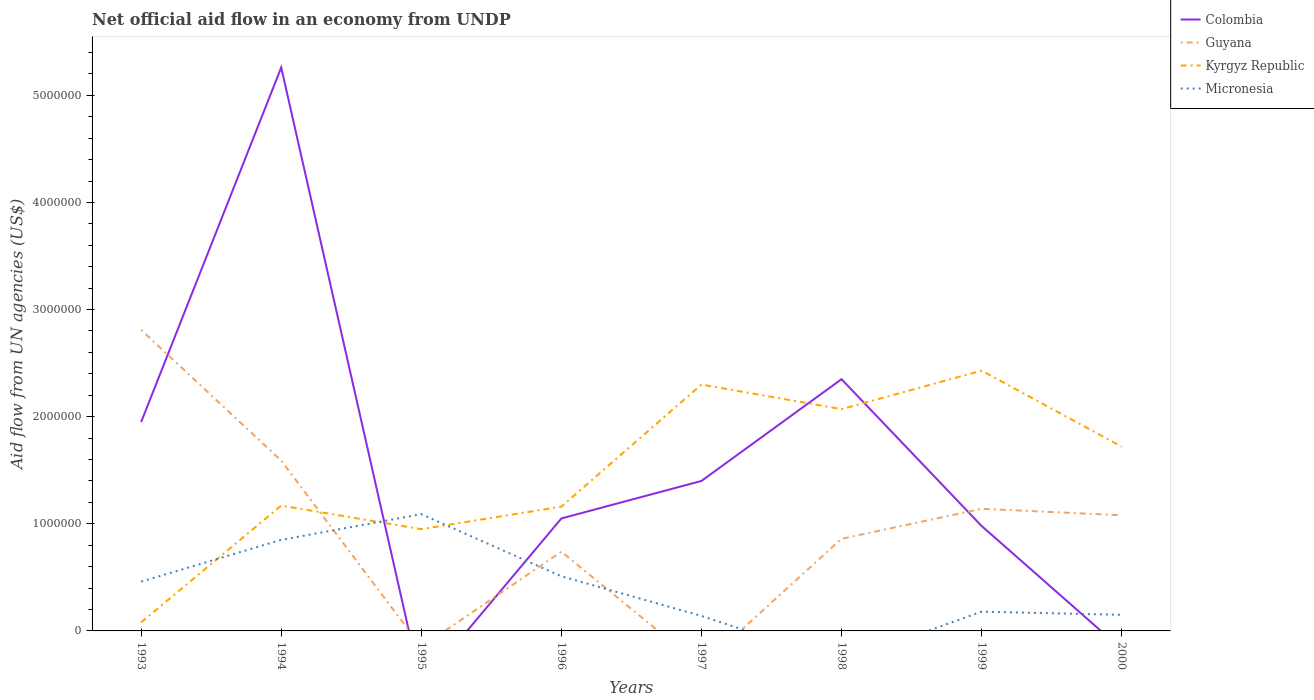How many different coloured lines are there?
Provide a succinct answer. 4. Is the number of lines equal to the number of legend labels?
Offer a terse response. No. Across all years, what is the maximum net official aid flow in Colombia?
Your response must be concise. 0. What is the difference between the highest and the second highest net official aid flow in Guyana?
Offer a terse response. 2.81e+06. What is the difference between the highest and the lowest net official aid flow in Micronesia?
Your response must be concise. 4. Is the net official aid flow in Kyrgyz Republic strictly greater than the net official aid flow in Micronesia over the years?
Ensure brevity in your answer.  No. How many lines are there?
Ensure brevity in your answer.  4. How many years are there in the graph?
Your answer should be very brief. 8. What is the difference between two consecutive major ticks on the Y-axis?
Your answer should be compact. 1.00e+06. Are the values on the major ticks of Y-axis written in scientific E-notation?
Keep it short and to the point. No. Does the graph contain any zero values?
Offer a very short reply. Yes. Does the graph contain grids?
Your response must be concise. No. How many legend labels are there?
Your response must be concise. 4. What is the title of the graph?
Keep it short and to the point. Net official aid flow in an economy from UNDP. What is the label or title of the Y-axis?
Your response must be concise. Aid flow from UN agencies (US$). What is the Aid flow from UN agencies (US$) in Colombia in 1993?
Offer a terse response. 1.95e+06. What is the Aid flow from UN agencies (US$) of Guyana in 1993?
Provide a short and direct response. 2.81e+06. What is the Aid flow from UN agencies (US$) of Kyrgyz Republic in 1993?
Provide a succinct answer. 8.00e+04. What is the Aid flow from UN agencies (US$) of Micronesia in 1993?
Keep it short and to the point. 4.60e+05. What is the Aid flow from UN agencies (US$) in Colombia in 1994?
Keep it short and to the point. 5.26e+06. What is the Aid flow from UN agencies (US$) in Guyana in 1994?
Make the answer very short. 1.59e+06. What is the Aid flow from UN agencies (US$) of Kyrgyz Republic in 1994?
Offer a terse response. 1.17e+06. What is the Aid flow from UN agencies (US$) of Micronesia in 1994?
Offer a very short reply. 8.50e+05. What is the Aid flow from UN agencies (US$) in Kyrgyz Republic in 1995?
Provide a short and direct response. 9.50e+05. What is the Aid flow from UN agencies (US$) of Micronesia in 1995?
Offer a very short reply. 1.09e+06. What is the Aid flow from UN agencies (US$) in Colombia in 1996?
Offer a very short reply. 1.05e+06. What is the Aid flow from UN agencies (US$) of Guyana in 1996?
Give a very brief answer. 7.40e+05. What is the Aid flow from UN agencies (US$) of Kyrgyz Republic in 1996?
Give a very brief answer. 1.16e+06. What is the Aid flow from UN agencies (US$) of Micronesia in 1996?
Give a very brief answer. 5.10e+05. What is the Aid flow from UN agencies (US$) in Colombia in 1997?
Provide a succinct answer. 1.40e+06. What is the Aid flow from UN agencies (US$) of Kyrgyz Republic in 1997?
Provide a short and direct response. 2.30e+06. What is the Aid flow from UN agencies (US$) of Colombia in 1998?
Your answer should be compact. 2.35e+06. What is the Aid flow from UN agencies (US$) of Guyana in 1998?
Make the answer very short. 8.60e+05. What is the Aid flow from UN agencies (US$) in Kyrgyz Republic in 1998?
Your response must be concise. 2.07e+06. What is the Aid flow from UN agencies (US$) in Micronesia in 1998?
Provide a succinct answer. 0. What is the Aid flow from UN agencies (US$) in Colombia in 1999?
Ensure brevity in your answer.  9.80e+05. What is the Aid flow from UN agencies (US$) of Guyana in 1999?
Provide a short and direct response. 1.14e+06. What is the Aid flow from UN agencies (US$) of Kyrgyz Republic in 1999?
Your answer should be very brief. 2.43e+06. What is the Aid flow from UN agencies (US$) of Colombia in 2000?
Ensure brevity in your answer.  0. What is the Aid flow from UN agencies (US$) in Guyana in 2000?
Ensure brevity in your answer.  1.08e+06. What is the Aid flow from UN agencies (US$) of Kyrgyz Republic in 2000?
Offer a terse response. 1.72e+06. What is the Aid flow from UN agencies (US$) of Micronesia in 2000?
Your answer should be compact. 1.50e+05. Across all years, what is the maximum Aid flow from UN agencies (US$) of Colombia?
Provide a succinct answer. 5.26e+06. Across all years, what is the maximum Aid flow from UN agencies (US$) in Guyana?
Provide a succinct answer. 2.81e+06. Across all years, what is the maximum Aid flow from UN agencies (US$) in Kyrgyz Republic?
Give a very brief answer. 2.43e+06. Across all years, what is the maximum Aid flow from UN agencies (US$) in Micronesia?
Your response must be concise. 1.09e+06. Across all years, what is the minimum Aid flow from UN agencies (US$) in Guyana?
Your answer should be very brief. 0. What is the total Aid flow from UN agencies (US$) in Colombia in the graph?
Provide a short and direct response. 1.30e+07. What is the total Aid flow from UN agencies (US$) of Guyana in the graph?
Your answer should be very brief. 8.22e+06. What is the total Aid flow from UN agencies (US$) in Kyrgyz Republic in the graph?
Offer a terse response. 1.19e+07. What is the total Aid flow from UN agencies (US$) in Micronesia in the graph?
Keep it short and to the point. 3.38e+06. What is the difference between the Aid flow from UN agencies (US$) of Colombia in 1993 and that in 1994?
Provide a succinct answer. -3.31e+06. What is the difference between the Aid flow from UN agencies (US$) of Guyana in 1993 and that in 1994?
Make the answer very short. 1.22e+06. What is the difference between the Aid flow from UN agencies (US$) in Kyrgyz Republic in 1993 and that in 1994?
Your answer should be compact. -1.09e+06. What is the difference between the Aid flow from UN agencies (US$) of Micronesia in 1993 and that in 1994?
Your answer should be very brief. -3.90e+05. What is the difference between the Aid flow from UN agencies (US$) of Kyrgyz Republic in 1993 and that in 1995?
Keep it short and to the point. -8.70e+05. What is the difference between the Aid flow from UN agencies (US$) of Micronesia in 1993 and that in 1995?
Offer a very short reply. -6.30e+05. What is the difference between the Aid flow from UN agencies (US$) in Guyana in 1993 and that in 1996?
Offer a very short reply. 2.07e+06. What is the difference between the Aid flow from UN agencies (US$) in Kyrgyz Republic in 1993 and that in 1996?
Offer a very short reply. -1.08e+06. What is the difference between the Aid flow from UN agencies (US$) of Kyrgyz Republic in 1993 and that in 1997?
Provide a succinct answer. -2.22e+06. What is the difference between the Aid flow from UN agencies (US$) of Micronesia in 1993 and that in 1997?
Keep it short and to the point. 3.20e+05. What is the difference between the Aid flow from UN agencies (US$) of Colombia in 1993 and that in 1998?
Your answer should be very brief. -4.00e+05. What is the difference between the Aid flow from UN agencies (US$) of Guyana in 1993 and that in 1998?
Offer a very short reply. 1.95e+06. What is the difference between the Aid flow from UN agencies (US$) in Kyrgyz Republic in 1993 and that in 1998?
Your answer should be compact. -1.99e+06. What is the difference between the Aid flow from UN agencies (US$) of Colombia in 1993 and that in 1999?
Offer a terse response. 9.70e+05. What is the difference between the Aid flow from UN agencies (US$) of Guyana in 1993 and that in 1999?
Offer a terse response. 1.67e+06. What is the difference between the Aid flow from UN agencies (US$) of Kyrgyz Republic in 1993 and that in 1999?
Your answer should be very brief. -2.35e+06. What is the difference between the Aid flow from UN agencies (US$) in Micronesia in 1993 and that in 1999?
Offer a terse response. 2.80e+05. What is the difference between the Aid flow from UN agencies (US$) in Guyana in 1993 and that in 2000?
Keep it short and to the point. 1.73e+06. What is the difference between the Aid flow from UN agencies (US$) in Kyrgyz Republic in 1993 and that in 2000?
Provide a succinct answer. -1.64e+06. What is the difference between the Aid flow from UN agencies (US$) of Micronesia in 1993 and that in 2000?
Your answer should be compact. 3.10e+05. What is the difference between the Aid flow from UN agencies (US$) of Kyrgyz Republic in 1994 and that in 1995?
Make the answer very short. 2.20e+05. What is the difference between the Aid flow from UN agencies (US$) in Micronesia in 1994 and that in 1995?
Provide a short and direct response. -2.40e+05. What is the difference between the Aid flow from UN agencies (US$) of Colombia in 1994 and that in 1996?
Give a very brief answer. 4.21e+06. What is the difference between the Aid flow from UN agencies (US$) of Guyana in 1994 and that in 1996?
Provide a succinct answer. 8.50e+05. What is the difference between the Aid flow from UN agencies (US$) in Kyrgyz Republic in 1994 and that in 1996?
Give a very brief answer. 10000. What is the difference between the Aid flow from UN agencies (US$) of Micronesia in 1994 and that in 1996?
Provide a short and direct response. 3.40e+05. What is the difference between the Aid flow from UN agencies (US$) in Colombia in 1994 and that in 1997?
Give a very brief answer. 3.86e+06. What is the difference between the Aid flow from UN agencies (US$) in Kyrgyz Republic in 1994 and that in 1997?
Ensure brevity in your answer.  -1.13e+06. What is the difference between the Aid flow from UN agencies (US$) in Micronesia in 1994 and that in 1997?
Provide a succinct answer. 7.10e+05. What is the difference between the Aid flow from UN agencies (US$) in Colombia in 1994 and that in 1998?
Offer a terse response. 2.91e+06. What is the difference between the Aid flow from UN agencies (US$) in Guyana in 1994 and that in 1998?
Your answer should be very brief. 7.30e+05. What is the difference between the Aid flow from UN agencies (US$) of Kyrgyz Republic in 1994 and that in 1998?
Ensure brevity in your answer.  -9.00e+05. What is the difference between the Aid flow from UN agencies (US$) of Colombia in 1994 and that in 1999?
Your answer should be very brief. 4.28e+06. What is the difference between the Aid flow from UN agencies (US$) of Guyana in 1994 and that in 1999?
Your response must be concise. 4.50e+05. What is the difference between the Aid flow from UN agencies (US$) in Kyrgyz Republic in 1994 and that in 1999?
Provide a short and direct response. -1.26e+06. What is the difference between the Aid flow from UN agencies (US$) in Micronesia in 1994 and that in 1999?
Provide a short and direct response. 6.70e+05. What is the difference between the Aid flow from UN agencies (US$) of Guyana in 1994 and that in 2000?
Give a very brief answer. 5.10e+05. What is the difference between the Aid flow from UN agencies (US$) of Kyrgyz Republic in 1994 and that in 2000?
Ensure brevity in your answer.  -5.50e+05. What is the difference between the Aid flow from UN agencies (US$) of Micronesia in 1995 and that in 1996?
Your response must be concise. 5.80e+05. What is the difference between the Aid flow from UN agencies (US$) of Kyrgyz Republic in 1995 and that in 1997?
Keep it short and to the point. -1.35e+06. What is the difference between the Aid flow from UN agencies (US$) in Micronesia in 1995 and that in 1997?
Offer a terse response. 9.50e+05. What is the difference between the Aid flow from UN agencies (US$) in Kyrgyz Republic in 1995 and that in 1998?
Offer a terse response. -1.12e+06. What is the difference between the Aid flow from UN agencies (US$) of Kyrgyz Republic in 1995 and that in 1999?
Give a very brief answer. -1.48e+06. What is the difference between the Aid flow from UN agencies (US$) of Micronesia in 1995 and that in 1999?
Give a very brief answer. 9.10e+05. What is the difference between the Aid flow from UN agencies (US$) in Kyrgyz Republic in 1995 and that in 2000?
Your answer should be compact. -7.70e+05. What is the difference between the Aid flow from UN agencies (US$) in Micronesia in 1995 and that in 2000?
Your answer should be very brief. 9.40e+05. What is the difference between the Aid flow from UN agencies (US$) in Colombia in 1996 and that in 1997?
Offer a very short reply. -3.50e+05. What is the difference between the Aid flow from UN agencies (US$) of Kyrgyz Republic in 1996 and that in 1997?
Give a very brief answer. -1.14e+06. What is the difference between the Aid flow from UN agencies (US$) in Colombia in 1996 and that in 1998?
Your response must be concise. -1.30e+06. What is the difference between the Aid flow from UN agencies (US$) of Kyrgyz Republic in 1996 and that in 1998?
Provide a succinct answer. -9.10e+05. What is the difference between the Aid flow from UN agencies (US$) of Colombia in 1996 and that in 1999?
Your answer should be compact. 7.00e+04. What is the difference between the Aid flow from UN agencies (US$) in Guyana in 1996 and that in 1999?
Your response must be concise. -4.00e+05. What is the difference between the Aid flow from UN agencies (US$) in Kyrgyz Republic in 1996 and that in 1999?
Provide a short and direct response. -1.27e+06. What is the difference between the Aid flow from UN agencies (US$) in Micronesia in 1996 and that in 1999?
Provide a succinct answer. 3.30e+05. What is the difference between the Aid flow from UN agencies (US$) of Guyana in 1996 and that in 2000?
Provide a succinct answer. -3.40e+05. What is the difference between the Aid flow from UN agencies (US$) in Kyrgyz Republic in 1996 and that in 2000?
Give a very brief answer. -5.60e+05. What is the difference between the Aid flow from UN agencies (US$) of Micronesia in 1996 and that in 2000?
Provide a short and direct response. 3.60e+05. What is the difference between the Aid flow from UN agencies (US$) in Colombia in 1997 and that in 1998?
Offer a very short reply. -9.50e+05. What is the difference between the Aid flow from UN agencies (US$) in Kyrgyz Republic in 1997 and that in 1998?
Keep it short and to the point. 2.30e+05. What is the difference between the Aid flow from UN agencies (US$) in Colombia in 1997 and that in 1999?
Provide a short and direct response. 4.20e+05. What is the difference between the Aid flow from UN agencies (US$) in Kyrgyz Republic in 1997 and that in 1999?
Provide a succinct answer. -1.30e+05. What is the difference between the Aid flow from UN agencies (US$) in Kyrgyz Republic in 1997 and that in 2000?
Your response must be concise. 5.80e+05. What is the difference between the Aid flow from UN agencies (US$) of Micronesia in 1997 and that in 2000?
Provide a short and direct response. -10000. What is the difference between the Aid flow from UN agencies (US$) of Colombia in 1998 and that in 1999?
Ensure brevity in your answer.  1.37e+06. What is the difference between the Aid flow from UN agencies (US$) of Guyana in 1998 and that in 1999?
Your answer should be compact. -2.80e+05. What is the difference between the Aid flow from UN agencies (US$) in Kyrgyz Republic in 1998 and that in 1999?
Your answer should be compact. -3.60e+05. What is the difference between the Aid flow from UN agencies (US$) in Guyana in 1998 and that in 2000?
Offer a very short reply. -2.20e+05. What is the difference between the Aid flow from UN agencies (US$) in Guyana in 1999 and that in 2000?
Offer a terse response. 6.00e+04. What is the difference between the Aid flow from UN agencies (US$) of Kyrgyz Republic in 1999 and that in 2000?
Your answer should be compact. 7.10e+05. What is the difference between the Aid flow from UN agencies (US$) in Colombia in 1993 and the Aid flow from UN agencies (US$) in Kyrgyz Republic in 1994?
Provide a succinct answer. 7.80e+05. What is the difference between the Aid flow from UN agencies (US$) in Colombia in 1993 and the Aid flow from UN agencies (US$) in Micronesia in 1994?
Provide a succinct answer. 1.10e+06. What is the difference between the Aid flow from UN agencies (US$) in Guyana in 1993 and the Aid flow from UN agencies (US$) in Kyrgyz Republic in 1994?
Offer a very short reply. 1.64e+06. What is the difference between the Aid flow from UN agencies (US$) of Guyana in 1993 and the Aid flow from UN agencies (US$) of Micronesia in 1994?
Make the answer very short. 1.96e+06. What is the difference between the Aid flow from UN agencies (US$) in Kyrgyz Republic in 1993 and the Aid flow from UN agencies (US$) in Micronesia in 1994?
Keep it short and to the point. -7.70e+05. What is the difference between the Aid flow from UN agencies (US$) in Colombia in 1993 and the Aid flow from UN agencies (US$) in Kyrgyz Republic in 1995?
Give a very brief answer. 1.00e+06. What is the difference between the Aid flow from UN agencies (US$) in Colombia in 1993 and the Aid flow from UN agencies (US$) in Micronesia in 1995?
Make the answer very short. 8.60e+05. What is the difference between the Aid flow from UN agencies (US$) of Guyana in 1993 and the Aid flow from UN agencies (US$) of Kyrgyz Republic in 1995?
Keep it short and to the point. 1.86e+06. What is the difference between the Aid flow from UN agencies (US$) in Guyana in 1993 and the Aid flow from UN agencies (US$) in Micronesia in 1995?
Give a very brief answer. 1.72e+06. What is the difference between the Aid flow from UN agencies (US$) of Kyrgyz Republic in 1993 and the Aid flow from UN agencies (US$) of Micronesia in 1995?
Offer a terse response. -1.01e+06. What is the difference between the Aid flow from UN agencies (US$) in Colombia in 1993 and the Aid flow from UN agencies (US$) in Guyana in 1996?
Your answer should be very brief. 1.21e+06. What is the difference between the Aid flow from UN agencies (US$) in Colombia in 1993 and the Aid flow from UN agencies (US$) in Kyrgyz Republic in 1996?
Make the answer very short. 7.90e+05. What is the difference between the Aid flow from UN agencies (US$) in Colombia in 1993 and the Aid flow from UN agencies (US$) in Micronesia in 1996?
Provide a short and direct response. 1.44e+06. What is the difference between the Aid flow from UN agencies (US$) of Guyana in 1993 and the Aid flow from UN agencies (US$) of Kyrgyz Republic in 1996?
Provide a short and direct response. 1.65e+06. What is the difference between the Aid flow from UN agencies (US$) of Guyana in 1993 and the Aid flow from UN agencies (US$) of Micronesia in 1996?
Give a very brief answer. 2.30e+06. What is the difference between the Aid flow from UN agencies (US$) in Kyrgyz Republic in 1993 and the Aid flow from UN agencies (US$) in Micronesia in 1996?
Make the answer very short. -4.30e+05. What is the difference between the Aid flow from UN agencies (US$) in Colombia in 1993 and the Aid flow from UN agencies (US$) in Kyrgyz Republic in 1997?
Keep it short and to the point. -3.50e+05. What is the difference between the Aid flow from UN agencies (US$) in Colombia in 1993 and the Aid flow from UN agencies (US$) in Micronesia in 1997?
Offer a very short reply. 1.81e+06. What is the difference between the Aid flow from UN agencies (US$) of Guyana in 1993 and the Aid flow from UN agencies (US$) of Kyrgyz Republic in 1997?
Give a very brief answer. 5.10e+05. What is the difference between the Aid flow from UN agencies (US$) of Guyana in 1993 and the Aid flow from UN agencies (US$) of Micronesia in 1997?
Make the answer very short. 2.67e+06. What is the difference between the Aid flow from UN agencies (US$) of Kyrgyz Republic in 1993 and the Aid flow from UN agencies (US$) of Micronesia in 1997?
Offer a terse response. -6.00e+04. What is the difference between the Aid flow from UN agencies (US$) in Colombia in 1993 and the Aid flow from UN agencies (US$) in Guyana in 1998?
Provide a short and direct response. 1.09e+06. What is the difference between the Aid flow from UN agencies (US$) in Colombia in 1993 and the Aid flow from UN agencies (US$) in Kyrgyz Republic in 1998?
Make the answer very short. -1.20e+05. What is the difference between the Aid flow from UN agencies (US$) of Guyana in 1993 and the Aid flow from UN agencies (US$) of Kyrgyz Republic in 1998?
Ensure brevity in your answer.  7.40e+05. What is the difference between the Aid flow from UN agencies (US$) in Colombia in 1993 and the Aid flow from UN agencies (US$) in Guyana in 1999?
Offer a terse response. 8.10e+05. What is the difference between the Aid flow from UN agencies (US$) of Colombia in 1993 and the Aid flow from UN agencies (US$) of Kyrgyz Republic in 1999?
Provide a short and direct response. -4.80e+05. What is the difference between the Aid flow from UN agencies (US$) of Colombia in 1993 and the Aid flow from UN agencies (US$) of Micronesia in 1999?
Give a very brief answer. 1.77e+06. What is the difference between the Aid flow from UN agencies (US$) of Guyana in 1993 and the Aid flow from UN agencies (US$) of Kyrgyz Republic in 1999?
Provide a short and direct response. 3.80e+05. What is the difference between the Aid flow from UN agencies (US$) in Guyana in 1993 and the Aid flow from UN agencies (US$) in Micronesia in 1999?
Provide a succinct answer. 2.63e+06. What is the difference between the Aid flow from UN agencies (US$) in Kyrgyz Republic in 1993 and the Aid flow from UN agencies (US$) in Micronesia in 1999?
Give a very brief answer. -1.00e+05. What is the difference between the Aid flow from UN agencies (US$) in Colombia in 1993 and the Aid flow from UN agencies (US$) in Guyana in 2000?
Ensure brevity in your answer.  8.70e+05. What is the difference between the Aid flow from UN agencies (US$) in Colombia in 1993 and the Aid flow from UN agencies (US$) in Micronesia in 2000?
Provide a succinct answer. 1.80e+06. What is the difference between the Aid flow from UN agencies (US$) in Guyana in 1993 and the Aid flow from UN agencies (US$) in Kyrgyz Republic in 2000?
Ensure brevity in your answer.  1.09e+06. What is the difference between the Aid flow from UN agencies (US$) in Guyana in 1993 and the Aid flow from UN agencies (US$) in Micronesia in 2000?
Make the answer very short. 2.66e+06. What is the difference between the Aid flow from UN agencies (US$) of Colombia in 1994 and the Aid flow from UN agencies (US$) of Kyrgyz Republic in 1995?
Your answer should be very brief. 4.31e+06. What is the difference between the Aid flow from UN agencies (US$) of Colombia in 1994 and the Aid flow from UN agencies (US$) of Micronesia in 1995?
Give a very brief answer. 4.17e+06. What is the difference between the Aid flow from UN agencies (US$) of Guyana in 1994 and the Aid flow from UN agencies (US$) of Kyrgyz Republic in 1995?
Make the answer very short. 6.40e+05. What is the difference between the Aid flow from UN agencies (US$) of Colombia in 1994 and the Aid flow from UN agencies (US$) of Guyana in 1996?
Ensure brevity in your answer.  4.52e+06. What is the difference between the Aid flow from UN agencies (US$) in Colombia in 1994 and the Aid flow from UN agencies (US$) in Kyrgyz Republic in 1996?
Your answer should be very brief. 4.10e+06. What is the difference between the Aid flow from UN agencies (US$) of Colombia in 1994 and the Aid flow from UN agencies (US$) of Micronesia in 1996?
Offer a very short reply. 4.75e+06. What is the difference between the Aid flow from UN agencies (US$) of Guyana in 1994 and the Aid flow from UN agencies (US$) of Micronesia in 1996?
Provide a succinct answer. 1.08e+06. What is the difference between the Aid flow from UN agencies (US$) in Kyrgyz Republic in 1994 and the Aid flow from UN agencies (US$) in Micronesia in 1996?
Ensure brevity in your answer.  6.60e+05. What is the difference between the Aid flow from UN agencies (US$) in Colombia in 1994 and the Aid flow from UN agencies (US$) in Kyrgyz Republic in 1997?
Provide a short and direct response. 2.96e+06. What is the difference between the Aid flow from UN agencies (US$) in Colombia in 1994 and the Aid flow from UN agencies (US$) in Micronesia in 1997?
Provide a succinct answer. 5.12e+06. What is the difference between the Aid flow from UN agencies (US$) in Guyana in 1994 and the Aid flow from UN agencies (US$) in Kyrgyz Republic in 1997?
Give a very brief answer. -7.10e+05. What is the difference between the Aid flow from UN agencies (US$) of Guyana in 1994 and the Aid flow from UN agencies (US$) of Micronesia in 1997?
Keep it short and to the point. 1.45e+06. What is the difference between the Aid flow from UN agencies (US$) of Kyrgyz Republic in 1994 and the Aid flow from UN agencies (US$) of Micronesia in 1997?
Your answer should be compact. 1.03e+06. What is the difference between the Aid flow from UN agencies (US$) in Colombia in 1994 and the Aid flow from UN agencies (US$) in Guyana in 1998?
Provide a succinct answer. 4.40e+06. What is the difference between the Aid flow from UN agencies (US$) in Colombia in 1994 and the Aid flow from UN agencies (US$) in Kyrgyz Republic in 1998?
Provide a succinct answer. 3.19e+06. What is the difference between the Aid flow from UN agencies (US$) in Guyana in 1994 and the Aid flow from UN agencies (US$) in Kyrgyz Republic in 1998?
Keep it short and to the point. -4.80e+05. What is the difference between the Aid flow from UN agencies (US$) of Colombia in 1994 and the Aid flow from UN agencies (US$) of Guyana in 1999?
Give a very brief answer. 4.12e+06. What is the difference between the Aid flow from UN agencies (US$) in Colombia in 1994 and the Aid flow from UN agencies (US$) in Kyrgyz Republic in 1999?
Make the answer very short. 2.83e+06. What is the difference between the Aid flow from UN agencies (US$) of Colombia in 1994 and the Aid flow from UN agencies (US$) of Micronesia in 1999?
Offer a terse response. 5.08e+06. What is the difference between the Aid flow from UN agencies (US$) in Guyana in 1994 and the Aid flow from UN agencies (US$) in Kyrgyz Republic in 1999?
Your answer should be compact. -8.40e+05. What is the difference between the Aid flow from UN agencies (US$) of Guyana in 1994 and the Aid flow from UN agencies (US$) of Micronesia in 1999?
Keep it short and to the point. 1.41e+06. What is the difference between the Aid flow from UN agencies (US$) in Kyrgyz Republic in 1994 and the Aid flow from UN agencies (US$) in Micronesia in 1999?
Provide a short and direct response. 9.90e+05. What is the difference between the Aid flow from UN agencies (US$) in Colombia in 1994 and the Aid flow from UN agencies (US$) in Guyana in 2000?
Your answer should be compact. 4.18e+06. What is the difference between the Aid flow from UN agencies (US$) of Colombia in 1994 and the Aid flow from UN agencies (US$) of Kyrgyz Republic in 2000?
Your answer should be compact. 3.54e+06. What is the difference between the Aid flow from UN agencies (US$) in Colombia in 1994 and the Aid flow from UN agencies (US$) in Micronesia in 2000?
Make the answer very short. 5.11e+06. What is the difference between the Aid flow from UN agencies (US$) in Guyana in 1994 and the Aid flow from UN agencies (US$) in Micronesia in 2000?
Your response must be concise. 1.44e+06. What is the difference between the Aid flow from UN agencies (US$) of Kyrgyz Republic in 1994 and the Aid flow from UN agencies (US$) of Micronesia in 2000?
Give a very brief answer. 1.02e+06. What is the difference between the Aid flow from UN agencies (US$) of Kyrgyz Republic in 1995 and the Aid flow from UN agencies (US$) of Micronesia in 1996?
Provide a succinct answer. 4.40e+05. What is the difference between the Aid flow from UN agencies (US$) of Kyrgyz Republic in 1995 and the Aid flow from UN agencies (US$) of Micronesia in 1997?
Ensure brevity in your answer.  8.10e+05. What is the difference between the Aid flow from UN agencies (US$) of Kyrgyz Republic in 1995 and the Aid flow from UN agencies (US$) of Micronesia in 1999?
Offer a terse response. 7.70e+05. What is the difference between the Aid flow from UN agencies (US$) in Colombia in 1996 and the Aid flow from UN agencies (US$) in Kyrgyz Republic in 1997?
Provide a succinct answer. -1.25e+06. What is the difference between the Aid flow from UN agencies (US$) in Colombia in 1996 and the Aid flow from UN agencies (US$) in Micronesia in 1997?
Your answer should be compact. 9.10e+05. What is the difference between the Aid flow from UN agencies (US$) of Guyana in 1996 and the Aid flow from UN agencies (US$) of Kyrgyz Republic in 1997?
Offer a very short reply. -1.56e+06. What is the difference between the Aid flow from UN agencies (US$) of Guyana in 1996 and the Aid flow from UN agencies (US$) of Micronesia in 1997?
Provide a short and direct response. 6.00e+05. What is the difference between the Aid flow from UN agencies (US$) of Kyrgyz Republic in 1996 and the Aid flow from UN agencies (US$) of Micronesia in 1997?
Provide a succinct answer. 1.02e+06. What is the difference between the Aid flow from UN agencies (US$) of Colombia in 1996 and the Aid flow from UN agencies (US$) of Guyana in 1998?
Give a very brief answer. 1.90e+05. What is the difference between the Aid flow from UN agencies (US$) of Colombia in 1996 and the Aid flow from UN agencies (US$) of Kyrgyz Republic in 1998?
Make the answer very short. -1.02e+06. What is the difference between the Aid flow from UN agencies (US$) in Guyana in 1996 and the Aid flow from UN agencies (US$) in Kyrgyz Republic in 1998?
Give a very brief answer. -1.33e+06. What is the difference between the Aid flow from UN agencies (US$) of Colombia in 1996 and the Aid flow from UN agencies (US$) of Kyrgyz Republic in 1999?
Provide a succinct answer. -1.38e+06. What is the difference between the Aid flow from UN agencies (US$) of Colombia in 1996 and the Aid flow from UN agencies (US$) of Micronesia in 1999?
Offer a terse response. 8.70e+05. What is the difference between the Aid flow from UN agencies (US$) in Guyana in 1996 and the Aid flow from UN agencies (US$) in Kyrgyz Republic in 1999?
Your answer should be compact. -1.69e+06. What is the difference between the Aid flow from UN agencies (US$) in Guyana in 1996 and the Aid flow from UN agencies (US$) in Micronesia in 1999?
Provide a succinct answer. 5.60e+05. What is the difference between the Aid flow from UN agencies (US$) of Kyrgyz Republic in 1996 and the Aid flow from UN agencies (US$) of Micronesia in 1999?
Your answer should be very brief. 9.80e+05. What is the difference between the Aid flow from UN agencies (US$) in Colombia in 1996 and the Aid flow from UN agencies (US$) in Kyrgyz Republic in 2000?
Your response must be concise. -6.70e+05. What is the difference between the Aid flow from UN agencies (US$) in Guyana in 1996 and the Aid flow from UN agencies (US$) in Kyrgyz Republic in 2000?
Provide a short and direct response. -9.80e+05. What is the difference between the Aid flow from UN agencies (US$) in Guyana in 1996 and the Aid flow from UN agencies (US$) in Micronesia in 2000?
Offer a very short reply. 5.90e+05. What is the difference between the Aid flow from UN agencies (US$) in Kyrgyz Republic in 1996 and the Aid flow from UN agencies (US$) in Micronesia in 2000?
Ensure brevity in your answer.  1.01e+06. What is the difference between the Aid flow from UN agencies (US$) of Colombia in 1997 and the Aid flow from UN agencies (US$) of Guyana in 1998?
Provide a short and direct response. 5.40e+05. What is the difference between the Aid flow from UN agencies (US$) of Colombia in 1997 and the Aid flow from UN agencies (US$) of Kyrgyz Republic in 1998?
Make the answer very short. -6.70e+05. What is the difference between the Aid flow from UN agencies (US$) of Colombia in 1997 and the Aid flow from UN agencies (US$) of Guyana in 1999?
Give a very brief answer. 2.60e+05. What is the difference between the Aid flow from UN agencies (US$) of Colombia in 1997 and the Aid flow from UN agencies (US$) of Kyrgyz Republic in 1999?
Provide a short and direct response. -1.03e+06. What is the difference between the Aid flow from UN agencies (US$) in Colombia in 1997 and the Aid flow from UN agencies (US$) in Micronesia in 1999?
Offer a very short reply. 1.22e+06. What is the difference between the Aid flow from UN agencies (US$) in Kyrgyz Republic in 1997 and the Aid flow from UN agencies (US$) in Micronesia in 1999?
Give a very brief answer. 2.12e+06. What is the difference between the Aid flow from UN agencies (US$) of Colombia in 1997 and the Aid flow from UN agencies (US$) of Guyana in 2000?
Keep it short and to the point. 3.20e+05. What is the difference between the Aid flow from UN agencies (US$) of Colombia in 1997 and the Aid flow from UN agencies (US$) of Kyrgyz Republic in 2000?
Make the answer very short. -3.20e+05. What is the difference between the Aid flow from UN agencies (US$) in Colombia in 1997 and the Aid flow from UN agencies (US$) in Micronesia in 2000?
Your answer should be very brief. 1.25e+06. What is the difference between the Aid flow from UN agencies (US$) in Kyrgyz Republic in 1997 and the Aid flow from UN agencies (US$) in Micronesia in 2000?
Give a very brief answer. 2.15e+06. What is the difference between the Aid flow from UN agencies (US$) in Colombia in 1998 and the Aid flow from UN agencies (US$) in Guyana in 1999?
Provide a short and direct response. 1.21e+06. What is the difference between the Aid flow from UN agencies (US$) of Colombia in 1998 and the Aid flow from UN agencies (US$) of Micronesia in 1999?
Provide a short and direct response. 2.17e+06. What is the difference between the Aid flow from UN agencies (US$) in Guyana in 1998 and the Aid flow from UN agencies (US$) in Kyrgyz Republic in 1999?
Your answer should be compact. -1.57e+06. What is the difference between the Aid flow from UN agencies (US$) in Guyana in 1998 and the Aid flow from UN agencies (US$) in Micronesia in 1999?
Keep it short and to the point. 6.80e+05. What is the difference between the Aid flow from UN agencies (US$) in Kyrgyz Republic in 1998 and the Aid flow from UN agencies (US$) in Micronesia in 1999?
Your answer should be compact. 1.89e+06. What is the difference between the Aid flow from UN agencies (US$) of Colombia in 1998 and the Aid flow from UN agencies (US$) of Guyana in 2000?
Ensure brevity in your answer.  1.27e+06. What is the difference between the Aid flow from UN agencies (US$) of Colombia in 1998 and the Aid flow from UN agencies (US$) of Kyrgyz Republic in 2000?
Provide a succinct answer. 6.30e+05. What is the difference between the Aid flow from UN agencies (US$) of Colombia in 1998 and the Aid flow from UN agencies (US$) of Micronesia in 2000?
Offer a very short reply. 2.20e+06. What is the difference between the Aid flow from UN agencies (US$) of Guyana in 1998 and the Aid flow from UN agencies (US$) of Kyrgyz Republic in 2000?
Give a very brief answer. -8.60e+05. What is the difference between the Aid flow from UN agencies (US$) of Guyana in 1998 and the Aid flow from UN agencies (US$) of Micronesia in 2000?
Provide a succinct answer. 7.10e+05. What is the difference between the Aid flow from UN agencies (US$) of Kyrgyz Republic in 1998 and the Aid flow from UN agencies (US$) of Micronesia in 2000?
Offer a terse response. 1.92e+06. What is the difference between the Aid flow from UN agencies (US$) in Colombia in 1999 and the Aid flow from UN agencies (US$) in Kyrgyz Republic in 2000?
Provide a succinct answer. -7.40e+05. What is the difference between the Aid flow from UN agencies (US$) in Colombia in 1999 and the Aid flow from UN agencies (US$) in Micronesia in 2000?
Keep it short and to the point. 8.30e+05. What is the difference between the Aid flow from UN agencies (US$) in Guyana in 1999 and the Aid flow from UN agencies (US$) in Kyrgyz Republic in 2000?
Your answer should be compact. -5.80e+05. What is the difference between the Aid flow from UN agencies (US$) in Guyana in 1999 and the Aid flow from UN agencies (US$) in Micronesia in 2000?
Give a very brief answer. 9.90e+05. What is the difference between the Aid flow from UN agencies (US$) of Kyrgyz Republic in 1999 and the Aid flow from UN agencies (US$) of Micronesia in 2000?
Provide a short and direct response. 2.28e+06. What is the average Aid flow from UN agencies (US$) of Colombia per year?
Make the answer very short. 1.62e+06. What is the average Aid flow from UN agencies (US$) of Guyana per year?
Your answer should be compact. 1.03e+06. What is the average Aid flow from UN agencies (US$) of Kyrgyz Republic per year?
Your answer should be very brief. 1.48e+06. What is the average Aid flow from UN agencies (US$) of Micronesia per year?
Provide a short and direct response. 4.22e+05. In the year 1993, what is the difference between the Aid flow from UN agencies (US$) in Colombia and Aid flow from UN agencies (US$) in Guyana?
Your response must be concise. -8.60e+05. In the year 1993, what is the difference between the Aid flow from UN agencies (US$) of Colombia and Aid flow from UN agencies (US$) of Kyrgyz Republic?
Your response must be concise. 1.87e+06. In the year 1993, what is the difference between the Aid flow from UN agencies (US$) in Colombia and Aid flow from UN agencies (US$) in Micronesia?
Your answer should be very brief. 1.49e+06. In the year 1993, what is the difference between the Aid flow from UN agencies (US$) of Guyana and Aid flow from UN agencies (US$) of Kyrgyz Republic?
Offer a very short reply. 2.73e+06. In the year 1993, what is the difference between the Aid flow from UN agencies (US$) in Guyana and Aid flow from UN agencies (US$) in Micronesia?
Provide a short and direct response. 2.35e+06. In the year 1993, what is the difference between the Aid flow from UN agencies (US$) in Kyrgyz Republic and Aid flow from UN agencies (US$) in Micronesia?
Offer a very short reply. -3.80e+05. In the year 1994, what is the difference between the Aid flow from UN agencies (US$) of Colombia and Aid flow from UN agencies (US$) of Guyana?
Ensure brevity in your answer.  3.67e+06. In the year 1994, what is the difference between the Aid flow from UN agencies (US$) in Colombia and Aid flow from UN agencies (US$) in Kyrgyz Republic?
Ensure brevity in your answer.  4.09e+06. In the year 1994, what is the difference between the Aid flow from UN agencies (US$) of Colombia and Aid flow from UN agencies (US$) of Micronesia?
Offer a very short reply. 4.41e+06. In the year 1994, what is the difference between the Aid flow from UN agencies (US$) of Guyana and Aid flow from UN agencies (US$) of Micronesia?
Your response must be concise. 7.40e+05. In the year 1995, what is the difference between the Aid flow from UN agencies (US$) of Kyrgyz Republic and Aid flow from UN agencies (US$) of Micronesia?
Your response must be concise. -1.40e+05. In the year 1996, what is the difference between the Aid flow from UN agencies (US$) in Colombia and Aid flow from UN agencies (US$) in Guyana?
Offer a very short reply. 3.10e+05. In the year 1996, what is the difference between the Aid flow from UN agencies (US$) in Colombia and Aid flow from UN agencies (US$) in Micronesia?
Give a very brief answer. 5.40e+05. In the year 1996, what is the difference between the Aid flow from UN agencies (US$) of Guyana and Aid flow from UN agencies (US$) of Kyrgyz Republic?
Offer a very short reply. -4.20e+05. In the year 1996, what is the difference between the Aid flow from UN agencies (US$) in Guyana and Aid flow from UN agencies (US$) in Micronesia?
Ensure brevity in your answer.  2.30e+05. In the year 1996, what is the difference between the Aid flow from UN agencies (US$) of Kyrgyz Republic and Aid flow from UN agencies (US$) of Micronesia?
Provide a succinct answer. 6.50e+05. In the year 1997, what is the difference between the Aid flow from UN agencies (US$) of Colombia and Aid flow from UN agencies (US$) of Kyrgyz Republic?
Provide a short and direct response. -9.00e+05. In the year 1997, what is the difference between the Aid flow from UN agencies (US$) of Colombia and Aid flow from UN agencies (US$) of Micronesia?
Give a very brief answer. 1.26e+06. In the year 1997, what is the difference between the Aid flow from UN agencies (US$) of Kyrgyz Republic and Aid flow from UN agencies (US$) of Micronesia?
Keep it short and to the point. 2.16e+06. In the year 1998, what is the difference between the Aid flow from UN agencies (US$) of Colombia and Aid flow from UN agencies (US$) of Guyana?
Keep it short and to the point. 1.49e+06. In the year 1998, what is the difference between the Aid flow from UN agencies (US$) in Guyana and Aid flow from UN agencies (US$) in Kyrgyz Republic?
Offer a very short reply. -1.21e+06. In the year 1999, what is the difference between the Aid flow from UN agencies (US$) of Colombia and Aid flow from UN agencies (US$) of Guyana?
Ensure brevity in your answer.  -1.60e+05. In the year 1999, what is the difference between the Aid flow from UN agencies (US$) in Colombia and Aid flow from UN agencies (US$) in Kyrgyz Republic?
Give a very brief answer. -1.45e+06. In the year 1999, what is the difference between the Aid flow from UN agencies (US$) in Guyana and Aid flow from UN agencies (US$) in Kyrgyz Republic?
Your answer should be very brief. -1.29e+06. In the year 1999, what is the difference between the Aid flow from UN agencies (US$) in Guyana and Aid flow from UN agencies (US$) in Micronesia?
Ensure brevity in your answer.  9.60e+05. In the year 1999, what is the difference between the Aid flow from UN agencies (US$) of Kyrgyz Republic and Aid flow from UN agencies (US$) of Micronesia?
Provide a succinct answer. 2.25e+06. In the year 2000, what is the difference between the Aid flow from UN agencies (US$) in Guyana and Aid flow from UN agencies (US$) in Kyrgyz Republic?
Your response must be concise. -6.40e+05. In the year 2000, what is the difference between the Aid flow from UN agencies (US$) in Guyana and Aid flow from UN agencies (US$) in Micronesia?
Provide a short and direct response. 9.30e+05. In the year 2000, what is the difference between the Aid flow from UN agencies (US$) in Kyrgyz Republic and Aid flow from UN agencies (US$) in Micronesia?
Keep it short and to the point. 1.57e+06. What is the ratio of the Aid flow from UN agencies (US$) of Colombia in 1993 to that in 1994?
Give a very brief answer. 0.37. What is the ratio of the Aid flow from UN agencies (US$) of Guyana in 1993 to that in 1994?
Offer a terse response. 1.77. What is the ratio of the Aid flow from UN agencies (US$) of Kyrgyz Republic in 1993 to that in 1994?
Your answer should be very brief. 0.07. What is the ratio of the Aid flow from UN agencies (US$) of Micronesia in 1993 to that in 1994?
Make the answer very short. 0.54. What is the ratio of the Aid flow from UN agencies (US$) in Kyrgyz Republic in 1993 to that in 1995?
Offer a terse response. 0.08. What is the ratio of the Aid flow from UN agencies (US$) of Micronesia in 1993 to that in 1995?
Your response must be concise. 0.42. What is the ratio of the Aid flow from UN agencies (US$) in Colombia in 1993 to that in 1996?
Make the answer very short. 1.86. What is the ratio of the Aid flow from UN agencies (US$) in Guyana in 1993 to that in 1996?
Provide a succinct answer. 3.8. What is the ratio of the Aid flow from UN agencies (US$) of Kyrgyz Republic in 1993 to that in 1996?
Your response must be concise. 0.07. What is the ratio of the Aid flow from UN agencies (US$) in Micronesia in 1993 to that in 1996?
Offer a very short reply. 0.9. What is the ratio of the Aid flow from UN agencies (US$) in Colombia in 1993 to that in 1997?
Offer a very short reply. 1.39. What is the ratio of the Aid flow from UN agencies (US$) of Kyrgyz Republic in 1993 to that in 1997?
Ensure brevity in your answer.  0.03. What is the ratio of the Aid flow from UN agencies (US$) in Micronesia in 1993 to that in 1997?
Make the answer very short. 3.29. What is the ratio of the Aid flow from UN agencies (US$) of Colombia in 1993 to that in 1998?
Offer a very short reply. 0.83. What is the ratio of the Aid flow from UN agencies (US$) in Guyana in 1993 to that in 1998?
Give a very brief answer. 3.27. What is the ratio of the Aid flow from UN agencies (US$) of Kyrgyz Republic in 1993 to that in 1998?
Your answer should be very brief. 0.04. What is the ratio of the Aid flow from UN agencies (US$) in Colombia in 1993 to that in 1999?
Ensure brevity in your answer.  1.99. What is the ratio of the Aid flow from UN agencies (US$) in Guyana in 1993 to that in 1999?
Offer a terse response. 2.46. What is the ratio of the Aid flow from UN agencies (US$) of Kyrgyz Republic in 1993 to that in 1999?
Your answer should be very brief. 0.03. What is the ratio of the Aid flow from UN agencies (US$) of Micronesia in 1993 to that in 1999?
Give a very brief answer. 2.56. What is the ratio of the Aid flow from UN agencies (US$) of Guyana in 1993 to that in 2000?
Offer a very short reply. 2.6. What is the ratio of the Aid flow from UN agencies (US$) of Kyrgyz Republic in 1993 to that in 2000?
Give a very brief answer. 0.05. What is the ratio of the Aid flow from UN agencies (US$) of Micronesia in 1993 to that in 2000?
Offer a terse response. 3.07. What is the ratio of the Aid flow from UN agencies (US$) in Kyrgyz Republic in 1994 to that in 1995?
Your response must be concise. 1.23. What is the ratio of the Aid flow from UN agencies (US$) in Micronesia in 1994 to that in 1995?
Provide a succinct answer. 0.78. What is the ratio of the Aid flow from UN agencies (US$) of Colombia in 1994 to that in 1996?
Keep it short and to the point. 5.01. What is the ratio of the Aid flow from UN agencies (US$) in Guyana in 1994 to that in 1996?
Provide a short and direct response. 2.15. What is the ratio of the Aid flow from UN agencies (US$) of Kyrgyz Republic in 1994 to that in 1996?
Offer a terse response. 1.01. What is the ratio of the Aid flow from UN agencies (US$) in Micronesia in 1994 to that in 1996?
Keep it short and to the point. 1.67. What is the ratio of the Aid flow from UN agencies (US$) in Colombia in 1994 to that in 1997?
Provide a short and direct response. 3.76. What is the ratio of the Aid flow from UN agencies (US$) in Kyrgyz Republic in 1994 to that in 1997?
Offer a terse response. 0.51. What is the ratio of the Aid flow from UN agencies (US$) in Micronesia in 1994 to that in 1997?
Make the answer very short. 6.07. What is the ratio of the Aid flow from UN agencies (US$) of Colombia in 1994 to that in 1998?
Your answer should be very brief. 2.24. What is the ratio of the Aid flow from UN agencies (US$) in Guyana in 1994 to that in 1998?
Offer a terse response. 1.85. What is the ratio of the Aid flow from UN agencies (US$) of Kyrgyz Republic in 1994 to that in 1998?
Provide a short and direct response. 0.57. What is the ratio of the Aid flow from UN agencies (US$) of Colombia in 1994 to that in 1999?
Keep it short and to the point. 5.37. What is the ratio of the Aid flow from UN agencies (US$) in Guyana in 1994 to that in 1999?
Offer a very short reply. 1.39. What is the ratio of the Aid flow from UN agencies (US$) of Kyrgyz Republic in 1994 to that in 1999?
Provide a short and direct response. 0.48. What is the ratio of the Aid flow from UN agencies (US$) of Micronesia in 1994 to that in 1999?
Your answer should be compact. 4.72. What is the ratio of the Aid flow from UN agencies (US$) in Guyana in 1994 to that in 2000?
Keep it short and to the point. 1.47. What is the ratio of the Aid flow from UN agencies (US$) in Kyrgyz Republic in 1994 to that in 2000?
Offer a very short reply. 0.68. What is the ratio of the Aid flow from UN agencies (US$) in Micronesia in 1994 to that in 2000?
Your answer should be very brief. 5.67. What is the ratio of the Aid flow from UN agencies (US$) of Kyrgyz Republic in 1995 to that in 1996?
Offer a terse response. 0.82. What is the ratio of the Aid flow from UN agencies (US$) of Micronesia in 1995 to that in 1996?
Provide a short and direct response. 2.14. What is the ratio of the Aid flow from UN agencies (US$) in Kyrgyz Republic in 1995 to that in 1997?
Provide a succinct answer. 0.41. What is the ratio of the Aid flow from UN agencies (US$) of Micronesia in 1995 to that in 1997?
Your answer should be very brief. 7.79. What is the ratio of the Aid flow from UN agencies (US$) of Kyrgyz Republic in 1995 to that in 1998?
Keep it short and to the point. 0.46. What is the ratio of the Aid flow from UN agencies (US$) of Kyrgyz Republic in 1995 to that in 1999?
Make the answer very short. 0.39. What is the ratio of the Aid flow from UN agencies (US$) of Micronesia in 1995 to that in 1999?
Keep it short and to the point. 6.06. What is the ratio of the Aid flow from UN agencies (US$) in Kyrgyz Republic in 1995 to that in 2000?
Provide a short and direct response. 0.55. What is the ratio of the Aid flow from UN agencies (US$) in Micronesia in 1995 to that in 2000?
Your response must be concise. 7.27. What is the ratio of the Aid flow from UN agencies (US$) of Colombia in 1996 to that in 1997?
Give a very brief answer. 0.75. What is the ratio of the Aid flow from UN agencies (US$) in Kyrgyz Republic in 1996 to that in 1997?
Offer a very short reply. 0.5. What is the ratio of the Aid flow from UN agencies (US$) of Micronesia in 1996 to that in 1997?
Offer a very short reply. 3.64. What is the ratio of the Aid flow from UN agencies (US$) of Colombia in 1996 to that in 1998?
Provide a short and direct response. 0.45. What is the ratio of the Aid flow from UN agencies (US$) of Guyana in 1996 to that in 1998?
Your answer should be very brief. 0.86. What is the ratio of the Aid flow from UN agencies (US$) in Kyrgyz Republic in 1996 to that in 1998?
Provide a short and direct response. 0.56. What is the ratio of the Aid flow from UN agencies (US$) of Colombia in 1996 to that in 1999?
Offer a very short reply. 1.07. What is the ratio of the Aid flow from UN agencies (US$) of Guyana in 1996 to that in 1999?
Provide a succinct answer. 0.65. What is the ratio of the Aid flow from UN agencies (US$) of Kyrgyz Republic in 1996 to that in 1999?
Give a very brief answer. 0.48. What is the ratio of the Aid flow from UN agencies (US$) in Micronesia in 1996 to that in 1999?
Your response must be concise. 2.83. What is the ratio of the Aid flow from UN agencies (US$) in Guyana in 1996 to that in 2000?
Keep it short and to the point. 0.69. What is the ratio of the Aid flow from UN agencies (US$) of Kyrgyz Republic in 1996 to that in 2000?
Provide a succinct answer. 0.67. What is the ratio of the Aid flow from UN agencies (US$) of Colombia in 1997 to that in 1998?
Your answer should be very brief. 0.6. What is the ratio of the Aid flow from UN agencies (US$) in Kyrgyz Republic in 1997 to that in 1998?
Offer a very short reply. 1.11. What is the ratio of the Aid flow from UN agencies (US$) in Colombia in 1997 to that in 1999?
Your answer should be very brief. 1.43. What is the ratio of the Aid flow from UN agencies (US$) in Kyrgyz Republic in 1997 to that in 1999?
Your answer should be compact. 0.95. What is the ratio of the Aid flow from UN agencies (US$) in Micronesia in 1997 to that in 1999?
Keep it short and to the point. 0.78. What is the ratio of the Aid flow from UN agencies (US$) in Kyrgyz Republic in 1997 to that in 2000?
Offer a very short reply. 1.34. What is the ratio of the Aid flow from UN agencies (US$) of Colombia in 1998 to that in 1999?
Ensure brevity in your answer.  2.4. What is the ratio of the Aid flow from UN agencies (US$) of Guyana in 1998 to that in 1999?
Your response must be concise. 0.75. What is the ratio of the Aid flow from UN agencies (US$) of Kyrgyz Republic in 1998 to that in 1999?
Your response must be concise. 0.85. What is the ratio of the Aid flow from UN agencies (US$) in Guyana in 1998 to that in 2000?
Your answer should be very brief. 0.8. What is the ratio of the Aid flow from UN agencies (US$) in Kyrgyz Republic in 1998 to that in 2000?
Ensure brevity in your answer.  1.2. What is the ratio of the Aid flow from UN agencies (US$) in Guyana in 1999 to that in 2000?
Offer a terse response. 1.06. What is the ratio of the Aid flow from UN agencies (US$) of Kyrgyz Republic in 1999 to that in 2000?
Offer a terse response. 1.41. What is the difference between the highest and the second highest Aid flow from UN agencies (US$) in Colombia?
Make the answer very short. 2.91e+06. What is the difference between the highest and the second highest Aid flow from UN agencies (US$) in Guyana?
Your answer should be very brief. 1.22e+06. What is the difference between the highest and the second highest Aid flow from UN agencies (US$) in Kyrgyz Republic?
Provide a succinct answer. 1.30e+05. What is the difference between the highest and the second highest Aid flow from UN agencies (US$) of Micronesia?
Offer a terse response. 2.40e+05. What is the difference between the highest and the lowest Aid flow from UN agencies (US$) in Colombia?
Keep it short and to the point. 5.26e+06. What is the difference between the highest and the lowest Aid flow from UN agencies (US$) in Guyana?
Your response must be concise. 2.81e+06. What is the difference between the highest and the lowest Aid flow from UN agencies (US$) of Kyrgyz Republic?
Your response must be concise. 2.35e+06. What is the difference between the highest and the lowest Aid flow from UN agencies (US$) of Micronesia?
Your answer should be very brief. 1.09e+06. 